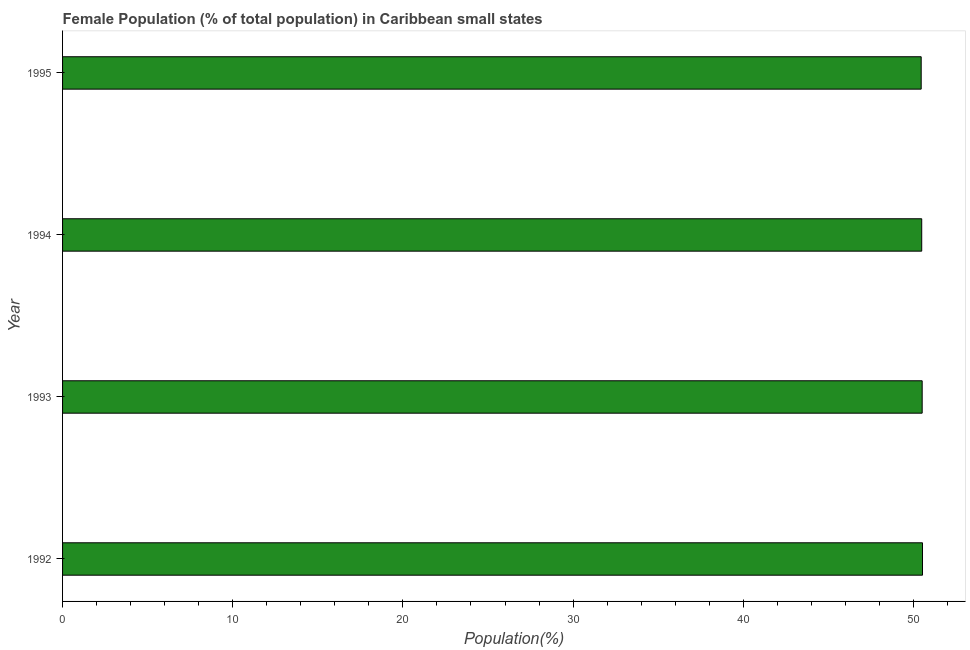What is the title of the graph?
Give a very brief answer. Female Population (% of total population) in Caribbean small states. What is the label or title of the X-axis?
Make the answer very short. Population(%). What is the female population in 1994?
Ensure brevity in your answer.  50.49. Across all years, what is the maximum female population?
Keep it short and to the point. 50.53. Across all years, what is the minimum female population?
Keep it short and to the point. 50.46. In which year was the female population minimum?
Your response must be concise. 1995. What is the sum of the female population?
Provide a short and direct response. 201.99. What is the difference between the female population in 1992 and 1995?
Keep it short and to the point. 0.08. What is the average female population per year?
Your answer should be very brief. 50.5. What is the median female population?
Ensure brevity in your answer.  50.5. Is the female population in 1992 less than that in 1995?
Make the answer very short. No. Is the difference between the female population in 1992 and 1994 greater than the difference between any two years?
Give a very brief answer. No. What is the difference between the highest and the second highest female population?
Give a very brief answer. 0.02. Is the sum of the female population in 1993 and 1995 greater than the maximum female population across all years?
Offer a very short reply. Yes. What is the difference between the highest and the lowest female population?
Your answer should be very brief. 0.08. What is the difference between two consecutive major ticks on the X-axis?
Your response must be concise. 10. Are the values on the major ticks of X-axis written in scientific E-notation?
Your answer should be compact. No. What is the Population(%) in 1992?
Your answer should be very brief. 50.53. What is the Population(%) in 1993?
Make the answer very short. 50.51. What is the Population(%) in 1994?
Offer a terse response. 50.49. What is the Population(%) of 1995?
Provide a succinct answer. 50.46. What is the difference between the Population(%) in 1992 and 1993?
Your answer should be compact. 0.02. What is the difference between the Population(%) in 1992 and 1994?
Give a very brief answer. 0.05. What is the difference between the Population(%) in 1992 and 1995?
Your response must be concise. 0.08. What is the difference between the Population(%) in 1993 and 1994?
Make the answer very short. 0.03. What is the difference between the Population(%) in 1993 and 1995?
Offer a very short reply. 0.06. What is the difference between the Population(%) in 1994 and 1995?
Keep it short and to the point. 0.03. What is the ratio of the Population(%) in 1992 to that in 1994?
Keep it short and to the point. 1. 